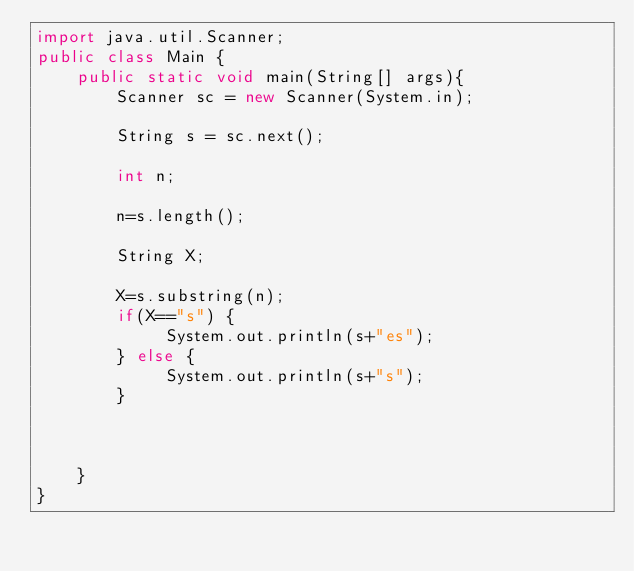<code> <loc_0><loc_0><loc_500><loc_500><_Java_>import java.util.Scanner;
public class Main {
    public static void main(String[] args){
        Scanner sc = new Scanner(System.in);

        String s = sc.next();

        int n;
        
        n=s.length();
        
        String X;
        
        X=s.substring(n);
        if(X=="s") {
        	 System.out.println(s+"es");
        } else {
        	 System.out.println(s+"s");
        }
        
    
       
    }
}
</code> 